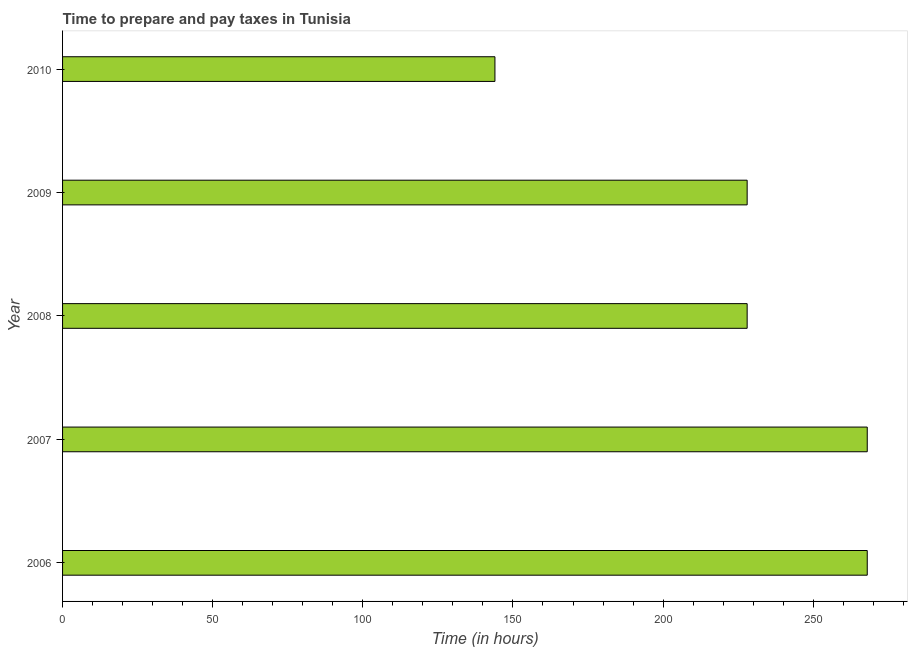Does the graph contain any zero values?
Ensure brevity in your answer.  No. What is the title of the graph?
Your answer should be compact. Time to prepare and pay taxes in Tunisia. What is the label or title of the X-axis?
Your answer should be compact. Time (in hours). What is the label or title of the Y-axis?
Offer a very short reply. Year. What is the time to prepare and pay taxes in 2006?
Provide a succinct answer. 268. Across all years, what is the maximum time to prepare and pay taxes?
Ensure brevity in your answer.  268. Across all years, what is the minimum time to prepare and pay taxes?
Give a very brief answer. 144. What is the sum of the time to prepare and pay taxes?
Give a very brief answer. 1136. What is the difference between the time to prepare and pay taxes in 2008 and 2010?
Ensure brevity in your answer.  84. What is the average time to prepare and pay taxes per year?
Give a very brief answer. 227. What is the median time to prepare and pay taxes?
Provide a succinct answer. 228. In how many years, is the time to prepare and pay taxes greater than 130 hours?
Give a very brief answer. 5. Do a majority of the years between 2010 and 2007 (inclusive) have time to prepare and pay taxes greater than 60 hours?
Your answer should be compact. Yes. What is the ratio of the time to prepare and pay taxes in 2006 to that in 2009?
Your response must be concise. 1.18. What is the difference between the highest and the second highest time to prepare and pay taxes?
Provide a succinct answer. 0. What is the difference between the highest and the lowest time to prepare and pay taxes?
Make the answer very short. 124. How many bars are there?
Your answer should be very brief. 5. Are all the bars in the graph horizontal?
Make the answer very short. Yes. How many years are there in the graph?
Offer a terse response. 5. Are the values on the major ticks of X-axis written in scientific E-notation?
Make the answer very short. No. What is the Time (in hours) in 2006?
Offer a very short reply. 268. What is the Time (in hours) of 2007?
Ensure brevity in your answer.  268. What is the Time (in hours) in 2008?
Keep it short and to the point. 228. What is the Time (in hours) of 2009?
Your answer should be compact. 228. What is the Time (in hours) in 2010?
Give a very brief answer. 144. What is the difference between the Time (in hours) in 2006 and 2007?
Ensure brevity in your answer.  0. What is the difference between the Time (in hours) in 2006 and 2010?
Offer a very short reply. 124. What is the difference between the Time (in hours) in 2007 and 2010?
Offer a very short reply. 124. What is the difference between the Time (in hours) in 2008 and 2009?
Your answer should be very brief. 0. What is the difference between the Time (in hours) in 2008 and 2010?
Your response must be concise. 84. What is the ratio of the Time (in hours) in 2006 to that in 2008?
Your answer should be very brief. 1.18. What is the ratio of the Time (in hours) in 2006 to that in 2009?
Keep it short and to the point. 1.18. What is the ratio of the Time (in hours) in 2006 to that in 2010?
Provide a short and direct response. 1.86. What is the ratio of the Time (in hours) in 2007 to that in 2008?
Provide a succinct answer. 1.18. What is the ratio of the Time (in hours) in 2007 to that in 2009?
Make the answer very short. 1.18. What is the ratio of the Time (in hours) in 2007 to that in 2010?
Offer a very short reply. 1.86. What is the ratio of the Time (in hours) in 2008 to that in 2010?
Offer a very short reply. 1.58. What is the ratio of the Time (in hours) in 2009 to that in 2010?
Give a very brief answer. 1.58. 